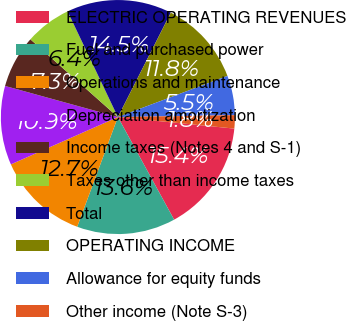<chart> <loc_0><loc_0><loc_500><loc_500><pie_chart><fcel>ELECTRIC OPERATING REVENUES<fcel>Fuel and purchased power<fcel>Operations and maintenance<fcel>Depreciation amortization<fcel>Income taxes (Notes 4 and S-1)<fcel>Taxes other than income taxes<fcel>Total<fcel>OPERATING INCOME<fcel>Allowance for equity funds<fcel>Other income (Note S-3)<nl><fcel>15.45%<fcel>13.63%<fcel>12.72%<fcel>10.91%<fcel>7.28%<fcel>6.37%<fcel>14.54%<fcel>11.82%<fcel>5.46%<fcel>1.83%<nl></chart> 